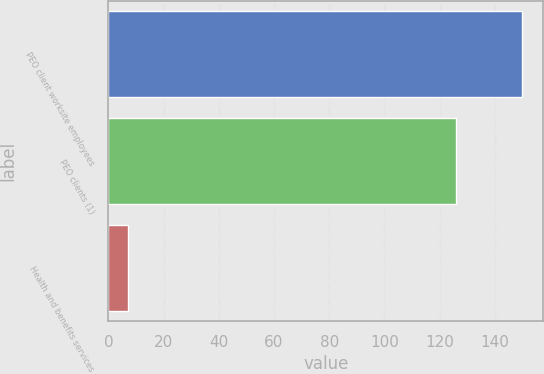Convert chart. <chart><loc_0><loc_0><loc_500><loc_500><bar_chart><fcel>PEO client worksite employees<fcel>PEO clients (1)<fcel>Health and benefits services<nl><fcel>150<fcel>126<fcel>7<nl></chart> 